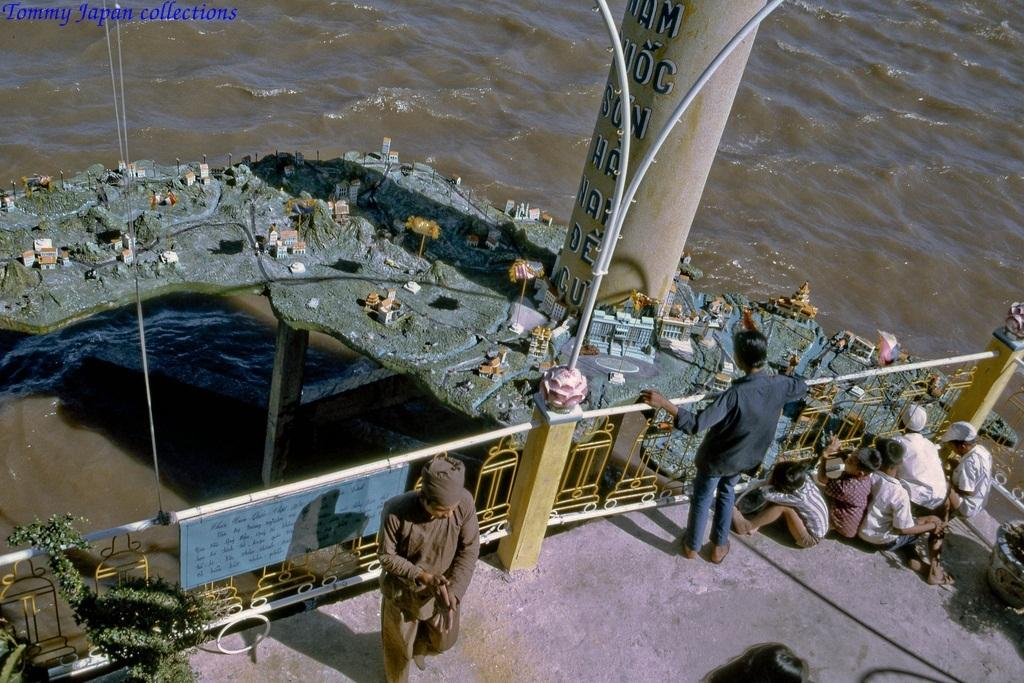How many people are in the image? There are people in the image, but the exact number cannot be determined from the provided facts. What type of structure can be seen in the image? The image contains railing, pillars, and poles, which suggest a structured environment. What is the board used for in the image? The purpose of the board in the image cannot be determined from the provided facts. What type of miniatures are present in the image? The type of miniatures in the image cannot be determined from the provided facts. What is the water visible in the image? The water in the image is visible, but its source or purpose cannot be determined from the provided facts. What type of plants are present in the image? The type of plants in the image cannot be determined from the provided facts. What type of silver is being used to plough the road in the image? There is no silver or road present in the image; it contains people, railing, pillars, poles, a board, miniatures, water, and plants. 